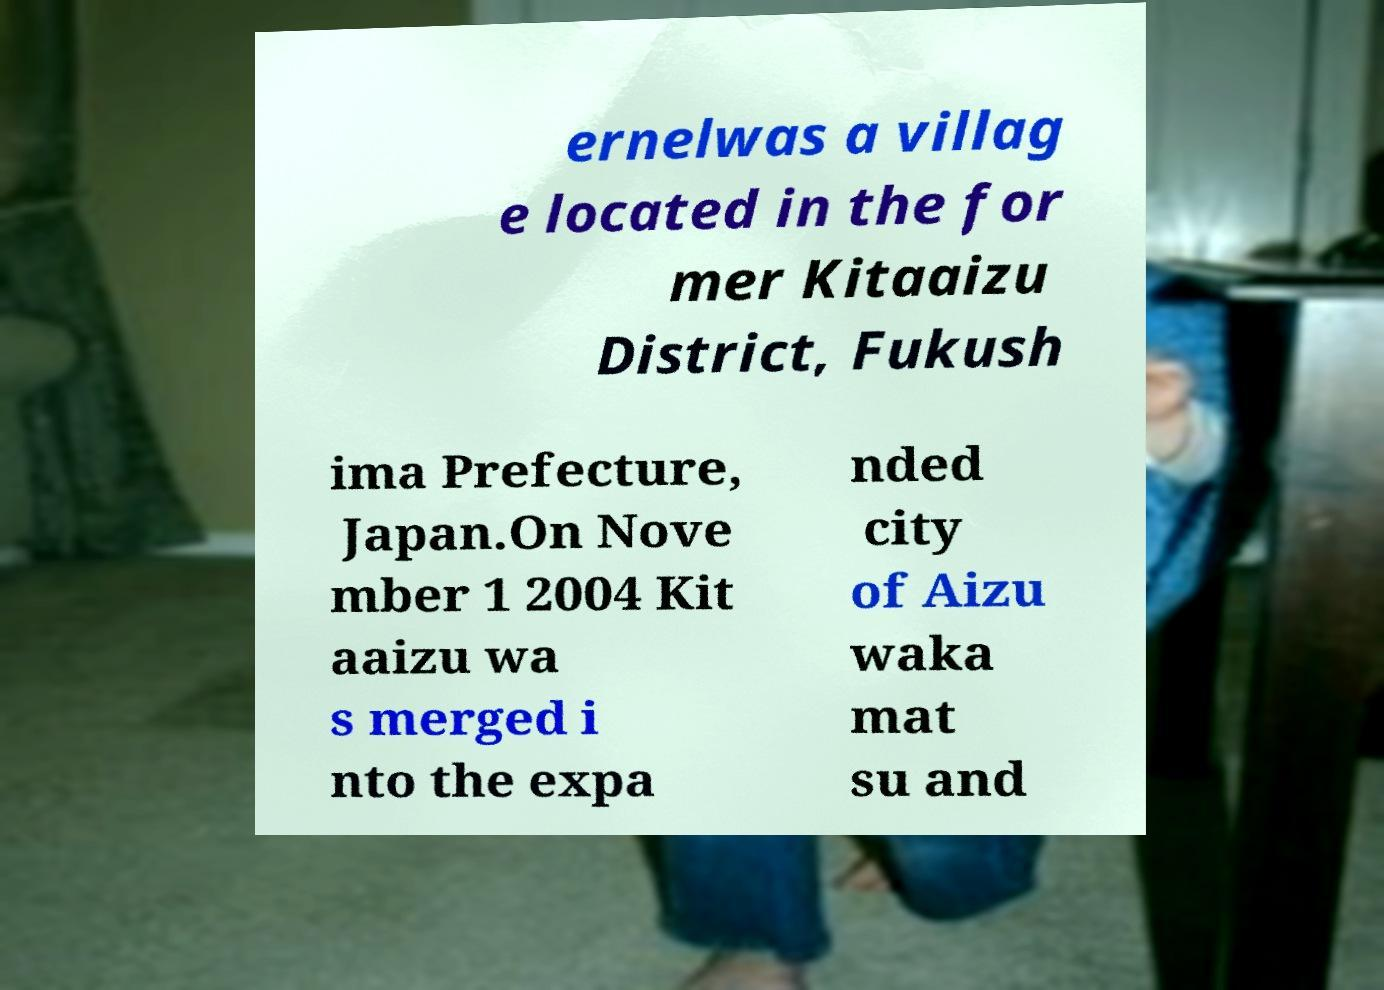I need the written content from this picture converted into text. Can you do that? ernelwas a villag e located in the for mer Kitaaizu District, Fukush ima Prefecture, Japan.On Nove mber 1 2004 Kit aaizu wa s merged i nto the expa nded city of Aizu waka mat su and 